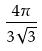<formula> <loc_0><loc_0><loc_500><loc_500>\frac { 4 \pi } { 3 \sqrt { 3 } }</formula> 